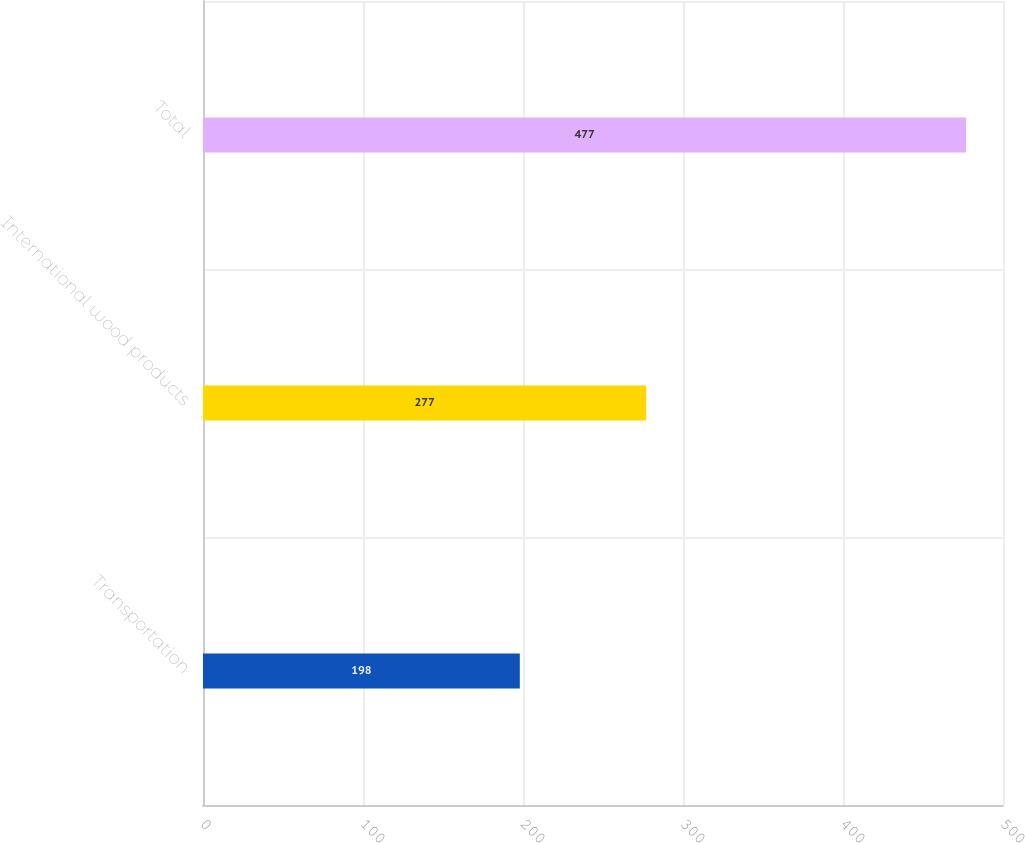Convert chart to OTSL. <chart><loc_0><loc_0><loc_500><loc_500><bar_chart><fcel>Transportation<fcel>International wood products<fcel>Total<nl><fcel>198<fcel>277<fcel>477<nl></chart> 